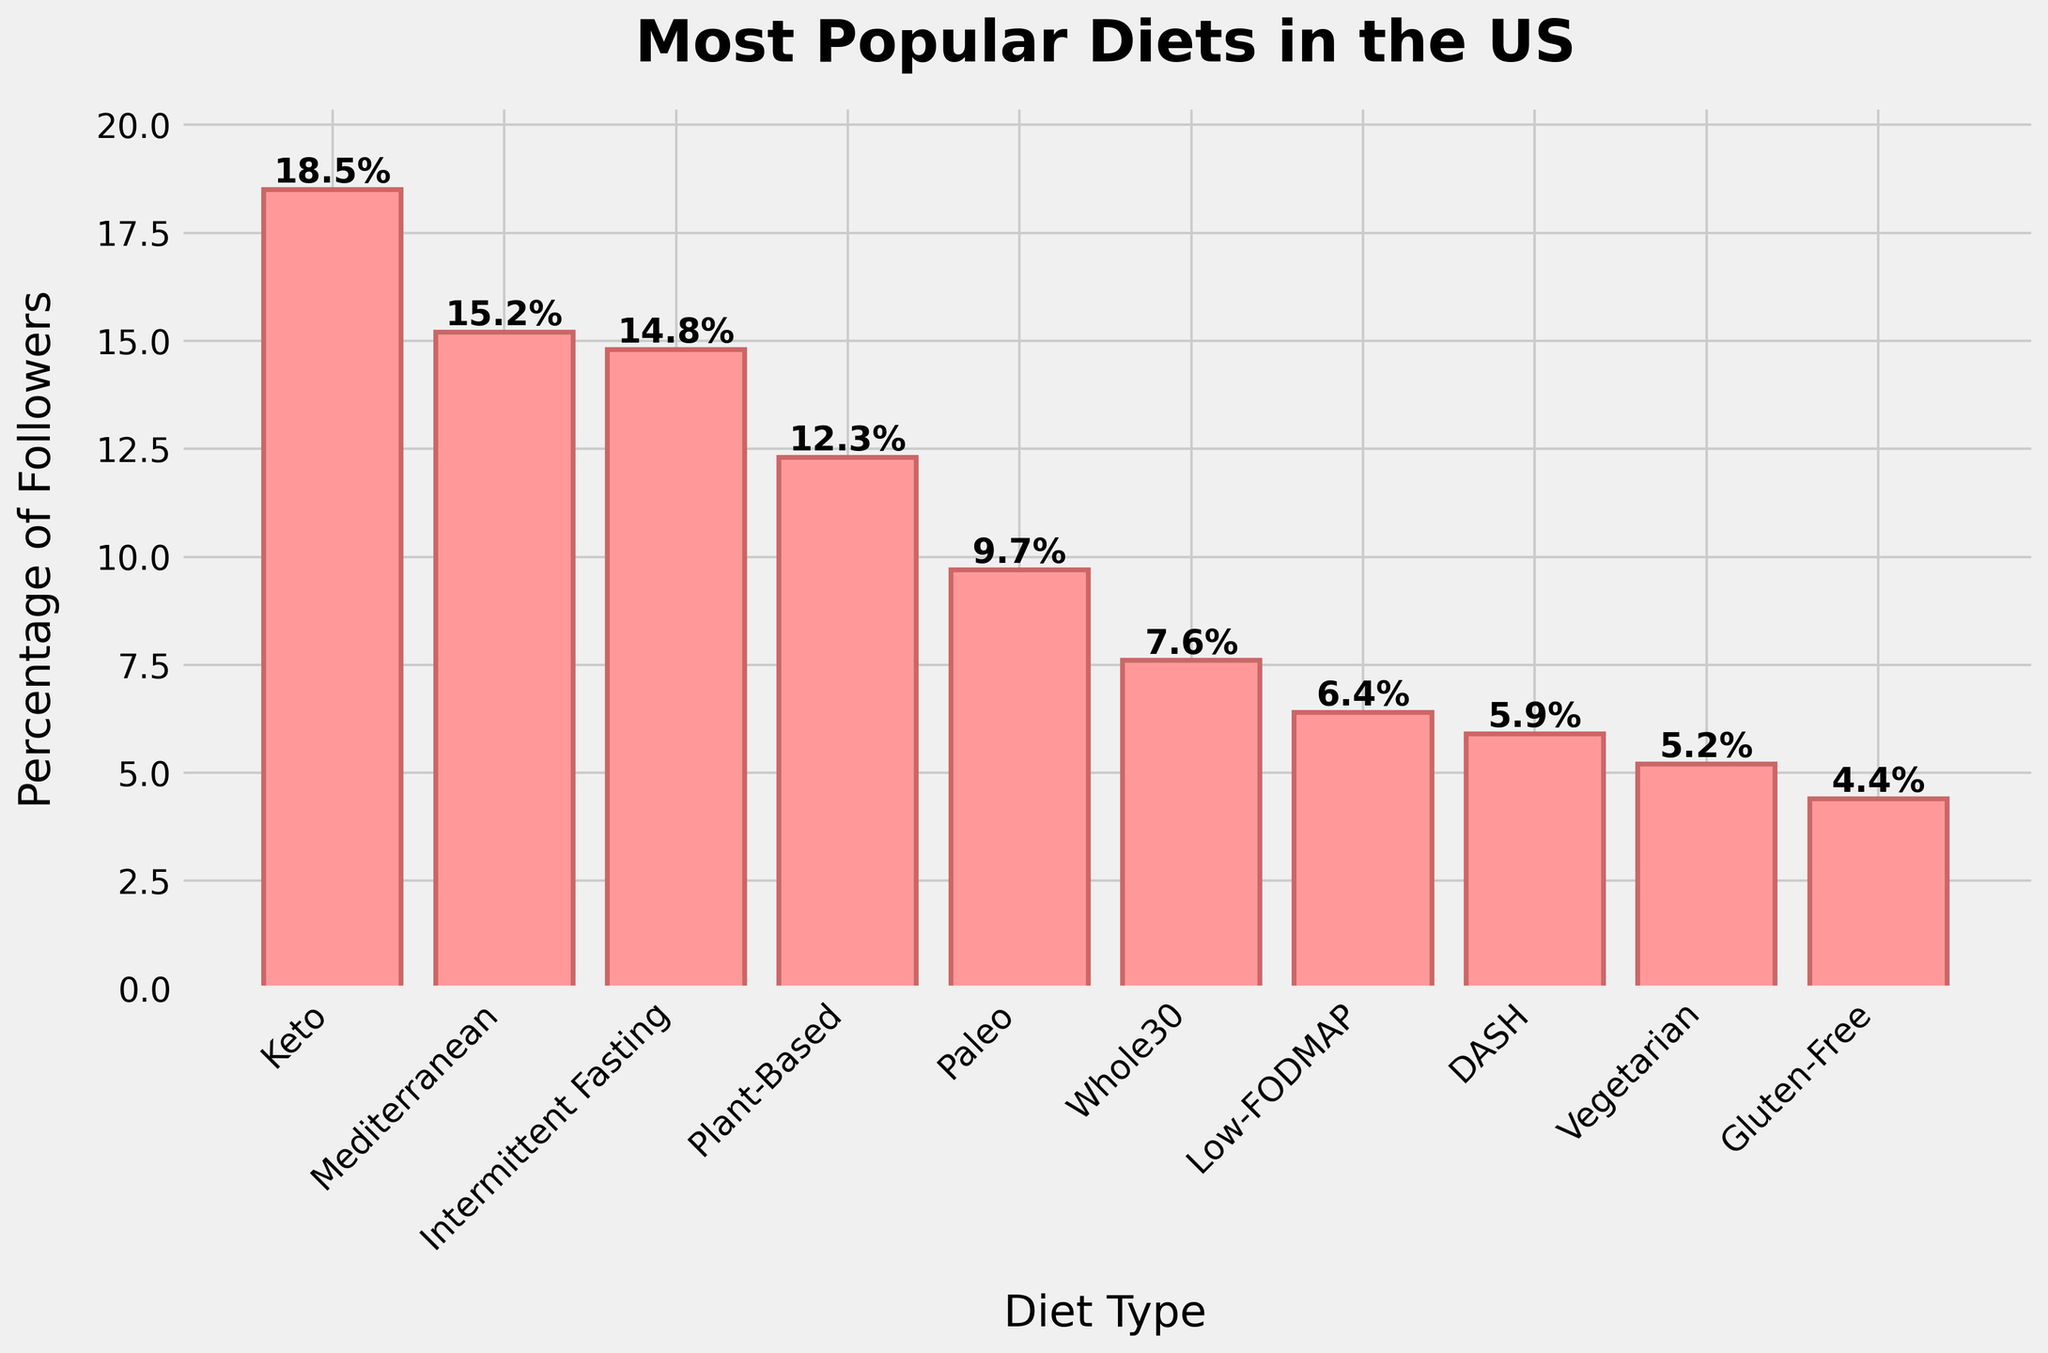What is the most popular diet in the US according to the chart? The chart shows the percentages of followers for various diets in the US. The highest percentage indicates the most popular diet. Keto has the highest percentage at 18.5%.
Answer: Keto Which diet has the lowest percentage of followers? To find the diet with the lowest percentage of followers, we look at the smallest bar in the chart. The Gluten-Free diet has the lowest percentage at 4.4%.
Answer: Gluten-Free How much more popular is the Keto diet compared to the Paleo diet? To determine how much more popular the Keto diet is compared to the Paleo diet, subtract the percentage of the Paleo diet from the percentage of the Keto diet. Keto is 18.5%, and Paleo is 9.7%, so 18.5% - 9.7% = 8.8%.
Answer: 8.8% Which diet is more popular, the Mediterranean diet or Intermittent Fasting, and by how much? Compare the percentages of the Mediterranean diet and Intermittent Fasting. The Mediterranean diet has 15.2%, and Intermittent Fasting has 14.8%. To find the difference, subtract 14.8% from 15.2%, which gives 0.4%.
Answer: Mediterranean by 0.4% What is the approximate total percentage of followers for the top three diets? Identify the top three diets and sum their percentages. The top three diets are Keto (18.5%), Mediterranean (15.2%), and Intermittent Fasting (14.8%). Adding these gives 18.5% + 15.2% + 14.8% = 48.5%.
Answer: 48.5% How many diets have a percentage of followers greater than 10%? Count the number of bars representing diets with percentages greater than 10%. The diets are Keto (18.5%), Mediterranean (15.2%), Intermittent Fasting (14.8%), and Plant-Based (12.3%). There are 4 diets.
Answer: 4 What is the percentage difference between Plant-Based and Vegetarian diets? Subtract the percentage of the Vegetarian diet from the Plant-Based diet. Plant-Based is 12.3%, and Vegetarian is 5.2%, so 12.3% - 5.2% = 7.1%.
Answer: 7.1% How does the height of the Whole30 bar visually compare to the Low-FODMAP bar? Visually, the Whole30 bar is taller than the Low-FODMAP bar.
Answer: Whole30 is taller Among the diets shown, which diets have a percentage of followers below 6%? Identify the bars with percentages less than 6%. DASH (5.9%), Vegetarian (5.2%), and Gluten-Free (4.4%) have percentages below 6%.
Answer: DASH, Vegetarian, Gluten-Free What is the average percentage of followers for Paleo, Whole30, and DASH diets? Add the percentages and then divide by the number of diets. Paleo is 9.7%, Whole30 is 7.6%, and DASH is 5.9%. Their total is 9.7% + 7.6% + 5.9% = 23.2%. To find the average: 23.2% / 3 = 7.73%.
Answer: 7.73% 